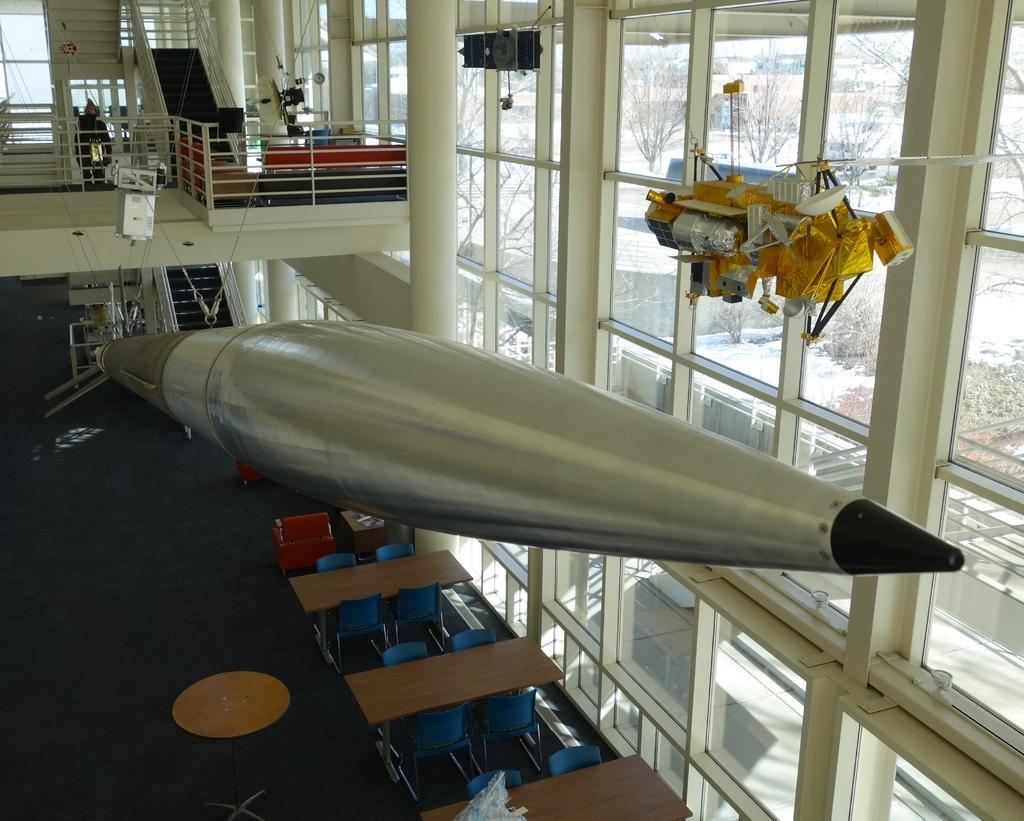Can you describe this image briefly? In a building there are few benches and chairs are arranged above that there is a metal rod hanging and above that there is a wall decor hanging beside that there is a first floor with furniture. 